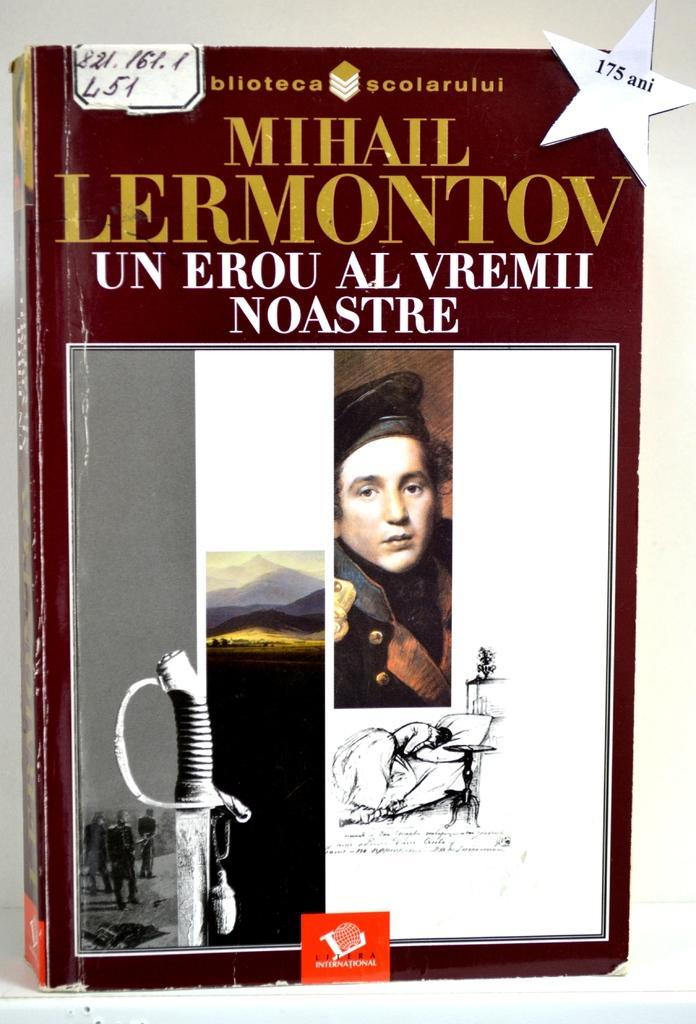What is the main subject in the foreground of the image? There is a book in the foreground of the image. What is the book placed on? The book is on a white surface. What can be seen on the book? The book has images and text on it. Can you tell me how many flights are mentioned in the book? There is no information about flights in the book; it only has images and text on it. Are there any trains depicted in the images on the book? There is no information about trains in the book; it only has images and text on it. 